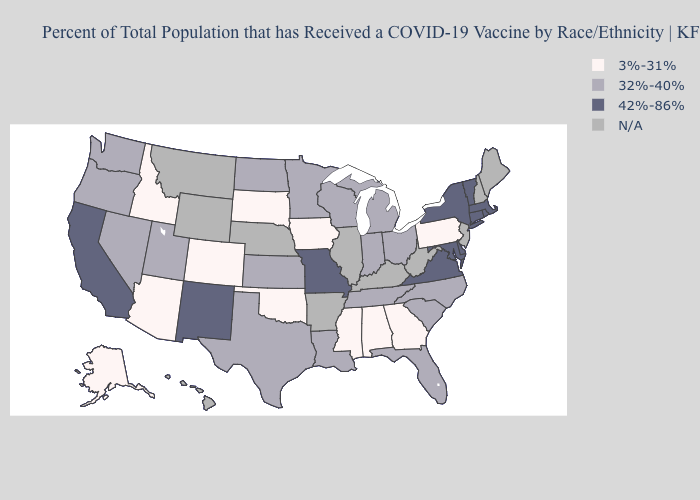Among the states that border Nevada , which have the highest value?
Concise answer only. California. What is the lowest value in the Northeast?
Give a very brief answer. 3%-31%. Does the map have missing data?
Quick response, please. Yes. What is the highest value in the MidWest ?
Concise answer only. 42%-86%. Among the states that border Colorado , which have the lowest value?
Keep it brief. Arizona, Oklahoma. Name the states that have a value in the range 3%-31%?
Keep it brief. Alabama, Alaska, Arizona, Colorado, Georgia, Idaho, Iowa, Mississippi, Oklahoma, Pennsylvania, South Dakota. What is the value of South Carolina?
Quick response, please. 32%-40%. What is the lowest value in the West?
Keep it brief. 3%-31%. How many symbols are there in the legend?
Answer briefly. 4. How many symbols are there in the legend?
Concise answer only. 4. Does the map have missing data?
Be succinct. Yes. Which states have the lowest value in the USA?
Concise answer only. Alabama, Alaska, Arizona, Colorado, Georgia, Idaho, Iowa, Mississippi, Oklahoma, Pennsylvania, South Dakota. What is the value of Alabama?
Quick response, please. 3%-31%. 